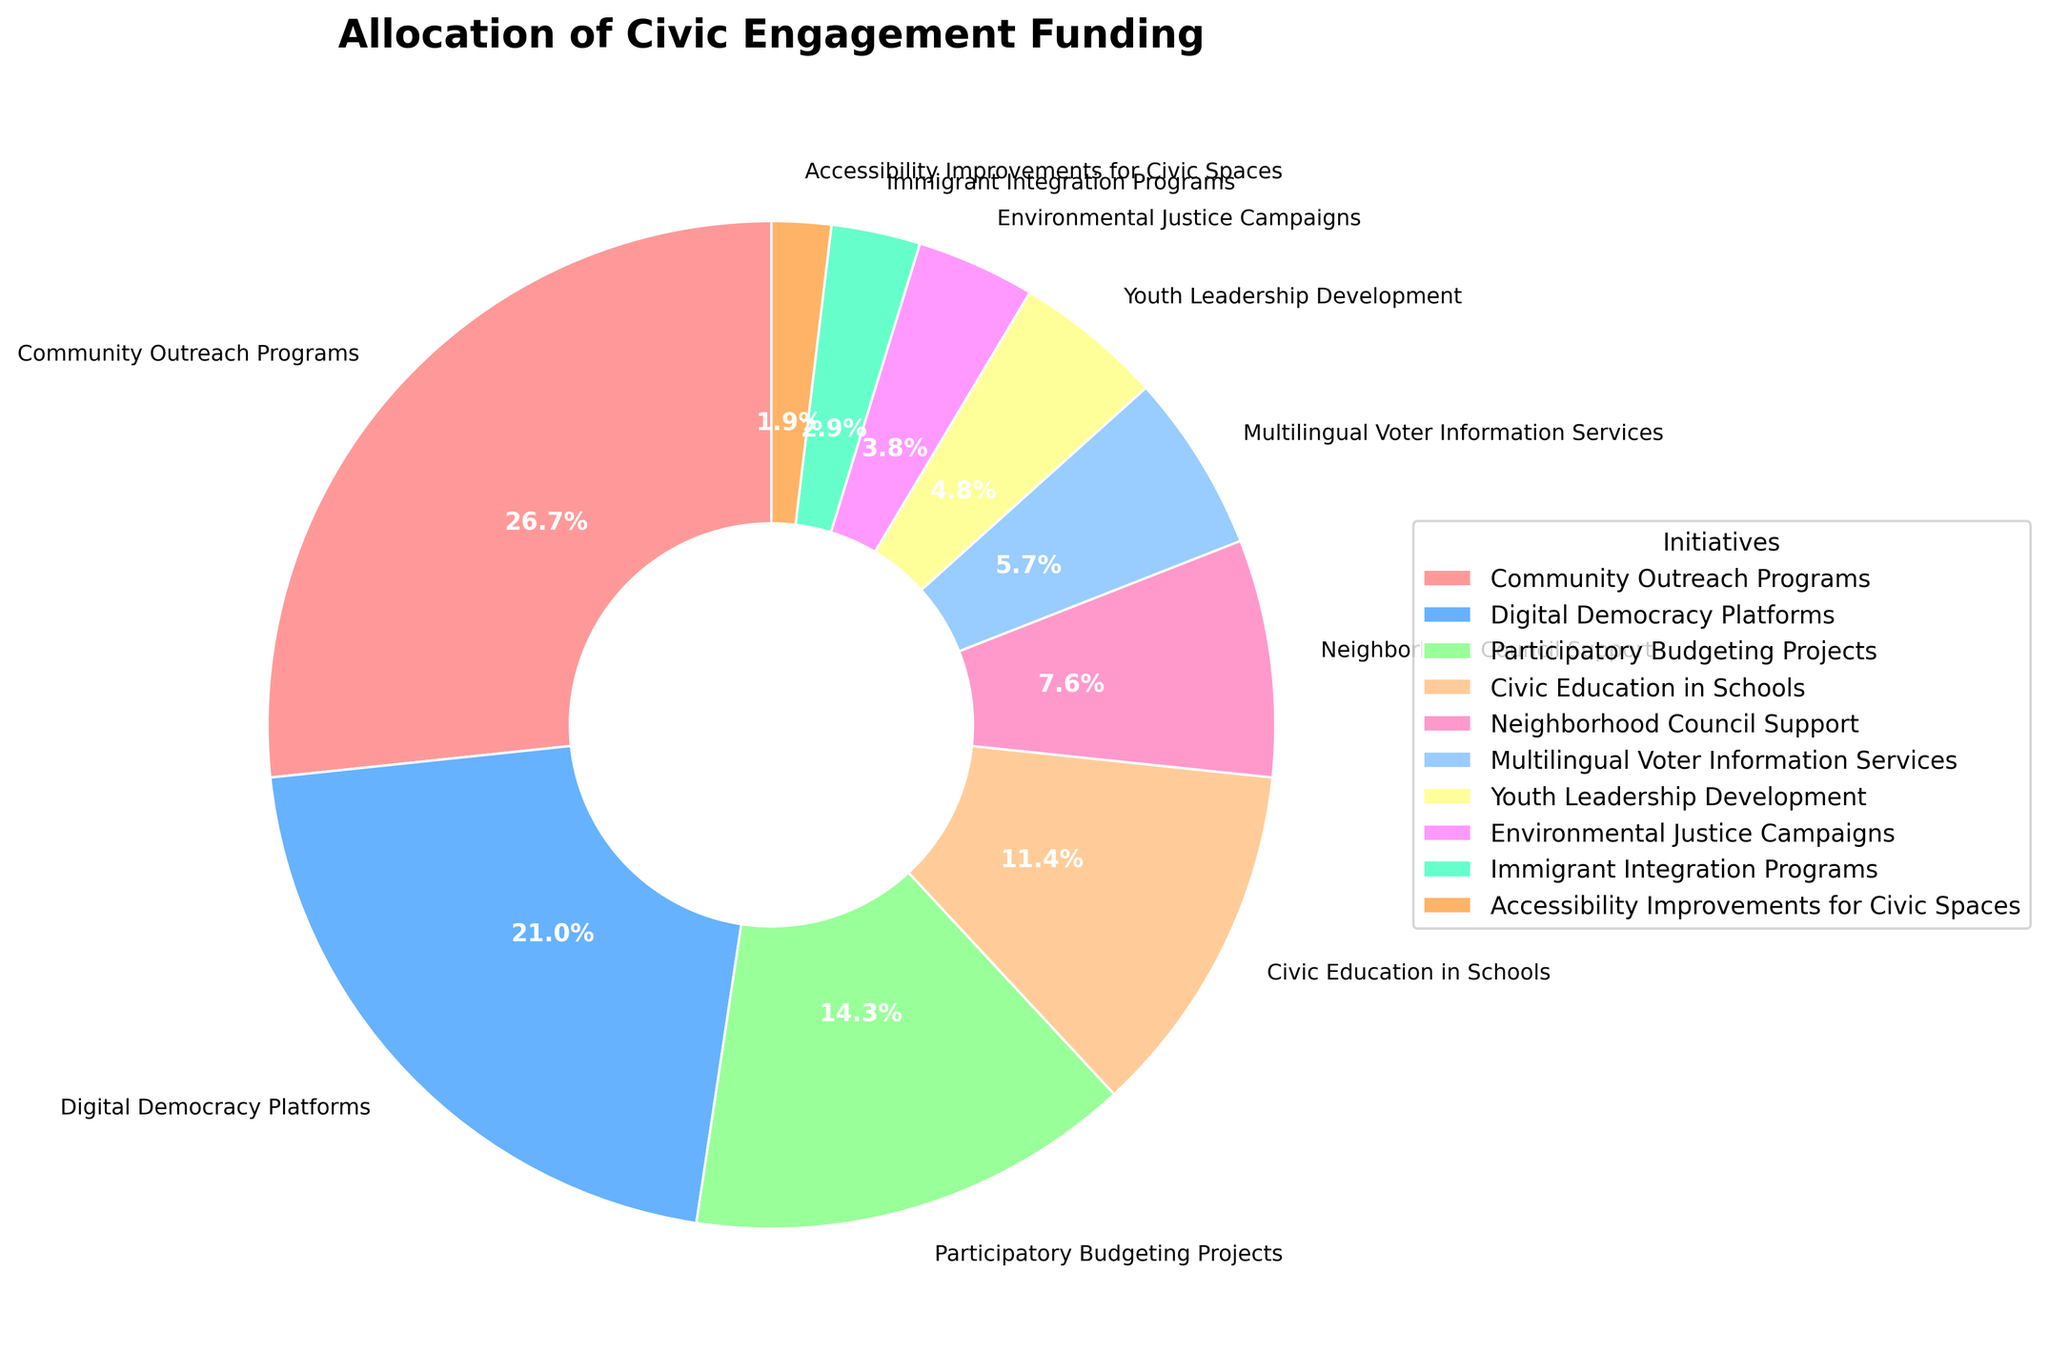What's the most heavily funded initiative? The largest section of the pie chart indicates the most heavily funded initiative, which is the Community Outreach Programs.
Answer: Community Outreach Programs Which initiative received the least amount of funding? The smallest section of the pie chart indicates the initiative with the least funding, which is Accessibility Improvements for Civic Spaces.
Answer: Accessibility Improvements for Civic Spaces How much more funding does Digital Democracy Platforms receive compared to Youth Leadership Development? Locate the funding percentage for Digital Democracy Platforms (22%) and Youth Leadership Development (5%). Then, calculate the difference: 22% - 5% = 17%.
Answer: 17% Which two initiatives have a combined allocation close to or equal to the allocation for Community Outreach Programs? Community Outreach Programs has an allocation of 28%. Looking for two initiatives whose combined allocations are close to 28%, we find Digital Democracy Platforms (22%) and Youth Leadership Development (5%), whose combined allocation is 22% + 5% = 27%.
Answer: Digital Democracy Platforms and Youth Leadership Development Rank the top three funded initiatives. Identify the largest three sections of the pie chart: Community Outreach Programs (28%), Digital Democracy Platforms (22%), Participatory Budgeting Projects (15%).
Answer: Community Outreach Programs, Digital Democracy Platforms, Participatory Budgeting Projects Which initiatives have funding allocations less than 5%? Identify sections of the pie chart with allocations less than 5%: Environmental Justice Campaigns (4%), Immigrant Integration Programs (3%), and Accessibility Improvements for Civic Spaces (2%).
Answer: Environmental Justice Campaigns, Immigrant Integration Programs, Accessibility Improvements for Civic Spaces What is the total funding allocation for initiatives related to education? Civic Education in Schools has a funding allocation of 12%. This is the only education-related initiative in the pie chart. Hence the total allocation is 12%.
Answer: 12% Approximately what fraction of the total funding is allocated to Civic Education in Schools and Neighborhood Council Support combined? Civic Education in Schools has 12% and Neighborhood Council Support has 8%. Combined is 12% + 8% = 20%, which is approximately 1/5 of the total funding (since 20% is 1/5 of 100%).
Answer: 1/5 